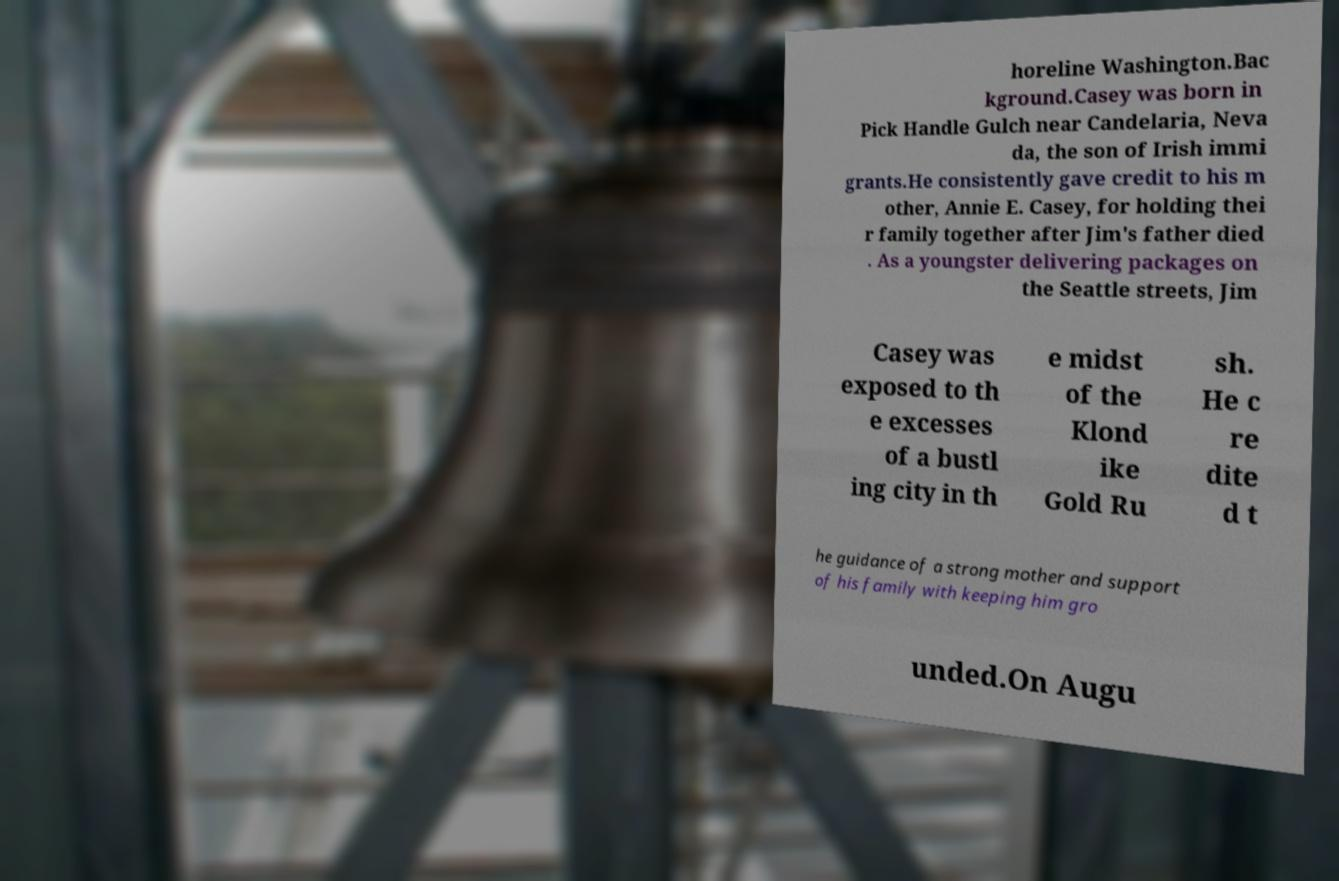Could you extract and type out the text from this image? horeline Washington.Bac kground.Casey was born in Pick Handle Gulch near Candelaria, Neva da, the son of Irish immi grants.He consistently gave credit to his m other, Annie E. Casey, for holding thei r family together after Jim's father died . As a youngster delivering packages on the Seattle streets, Jim Casey was exposed to th e excesses of a bustl ing city in th e midst of the Klond ike Gold Ru sh. He c re dite d t he guidance of a strong mother and support of his family with keeping him gro unded.On Augu 